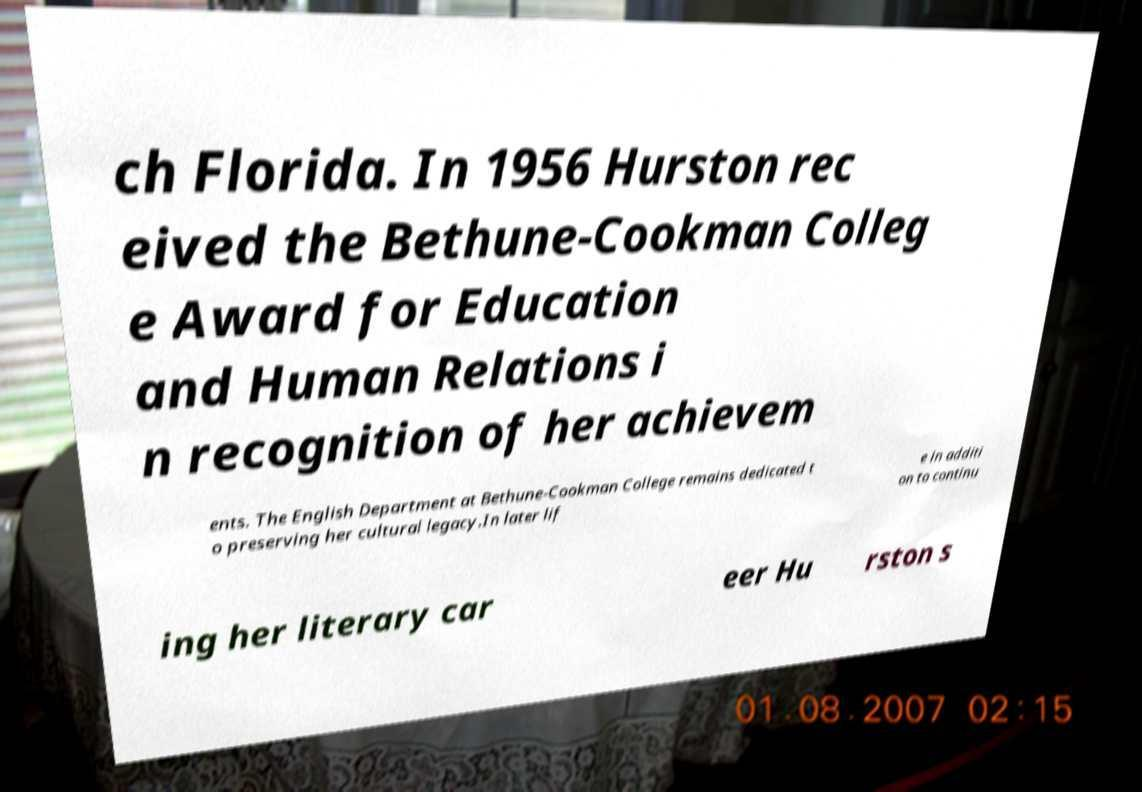I need the written content from this picture converted into text. Can you do that? ch Florida. In 1956 Hurston rec eived the Bethune-Cookman Colleg e Award for Education and Human Relations i n recognition of her achievem ents. The English Department at Bethune-Cookman College remains dedicated t o preserving her cultural legacy.In later lif e in additi on to continu ing her literary car eer Hu rston s 